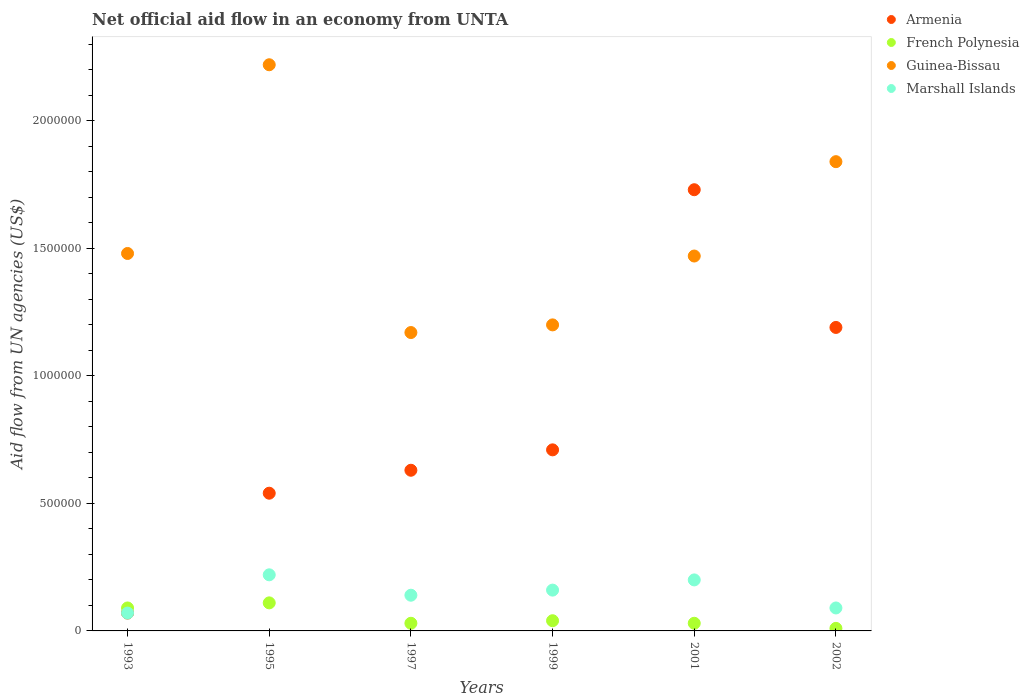What is the net official aid flow in French Polynesia in 2002?
Your answer should be compact. 10000. Across all years, what is the maximum net official aid flow in Marshall Islands?
Keep it short and to the point. 2.20e+05. In which year was the net official aid flow in Armenia maximum?
Your response must be concise. 2001. What is the total net official aid flow in Guinea-Bissau in the graph?
Ensure brevity in your answer.  9.38e+06. What is the difference between the net official aid flow in French Polynesia in 1993 and the net official aid flow in Guinea-Bissau in 1997?
Keep it short and to the point. -1.08e+06. What is the average net official aid flow in Marshall Islands per year?
Keep it short and to the point. 1.47e+05. In the year 1999, what is the difference between the net official aid flow in Guinea-Bissau and net official aid flow in Marshall Islands?
Provide a short and direct response. 1.04e+06. In how many years, is the net official aid flow in French Polynesia greater than 2200000 US$?
Ensure brevity in your answer.  0. What is the ratio of the net official aid flow in Guinea-Bissau in 1999 to that in 2001?
Ensure brevity in your answer.  0.82. What is the difference between the highest and the second highest net official aid flow in Guinea-Bissau?
Offer a very short reply. 3.80e+05. Is the sum of the net official aid flow in French Polynesia in 1999 and 2002 greater than the maximum net official aid flow in Armenia across all years?
Ensure brevity in your answer.  No. Is it the case that in every year, the sum of the net official aid flow in French Polynesia and net official aid flow in Armenia  is greater than the net official aid flow in Marshall Islands?
Keep it short and to the point. Yes. Does the net official aid flow in Armenia monotonically increase over the years?
Make the answer very short. No. How many years are there in the graph?
Your answer should be compact. 6. What is the difference between two consecutive major ticks on the Y-axis?
Offer a very short reply. 5.00e+05. Are the values on the major ticks of Y-axis written in scientific E-notation?
Offer a terse response. No. Does the graph contain any zero values?
Keep it short and to the point. No. How many legend labels are there?
Provide a short and direct response. 4. How are the legend labels stacked?
Your answer should be compact. Vertical. What is the title of the graph?
Offer a terse response. Net official aid flow in an economy from UNTA. Does "Denmark" appear as one of the legend labels in the graph?
Give a very brief answer. No. What is the label or title of the Y-axis?
Your response must be concise. Aid flow from UN agencies (US$). What is the Aid flow from UN agencies (US$) of French Polynesia in 1993?
Offer a terse response. 9.00e+04. What is the Aid flow from UN agencies (US$) in Guinea-Bissau in 1993?
Ensure brevity in your answer.  1.48e+06. What is the Aid flow from UN agencies (US$) in Armenia in 1995?
Your answer should be compact. 5.40e+05. What is the Aid flow from UN agencies (US$) of French Polynesia in 1995?
Give a very brief answer. 1.10e+05. What is the Aid flow from UN agencies (US$) of Guinea-Bissau in 1995?
Provide a short and direct response. 2.22e+06. What is the Aid flow from UN agencies (US$) of Marshall Islands in 1995?
Provide a short and direct response. 2.20e+05. What is the Aid flow from UN agencies (US$) of Armenia in 1997?
Keep it short and to the point. 6.30e+05. What is the Aid flow from UN agencies (US$) in Guinea-Bissau in 1997?
Your response must be concise. 1.17e+06. What is the Aid flow from UN agencies (US$) in Armenia in 1999?
Offer a very short reply. 7.10e+05. What is the Aid flow from UN agencies (US$) in Guinea-Bissau in 1999?
Provide a short and direct response. 1.20e+06. What is the Aid flow from UN agencies (US$) in Armenia in 2001?
Provide a succinct answer. 1.73e+06. What is the Aid flow from UN agencies (US$) in French Polynesia in 2001?
Offer a very short reply. 3.00e+04. What is the Aid flow from UN agencies (US$) in Guinea-Bissau in 2001?
Give a very brief answer. 1.47e+06. What is the Aid flow from UN agencies (US$) of Marshall Islands in 2001?
Give a very brief answer. 2.00e+05. What is the Aid flow from UN agencies (US$) of Armenia in 2002?
Your answer should be very brief. 1.19e+06. What is the Aid flow from UN agencies (US$) of Guinea-Bissau in 2002?
Provide a short and direct response. 1.84e+06. What is the Aid flow from UN agencies (US$) in Marshall Islands in 2002?
Offer a terse response. 9.00e+04. Across all years, what is the maximum Aid flow from UN agencies (US$) of Armenia?
Offer a terse response. 1.73e+06. Across all years, what is the maximum Aid flow from UN agencies (US$) in French Polynesia?
Offer a very short reply. 1.10e+05. Across all years, what is the maximum Aid flow from UN agencies (US$) of Guinea-Bissau?
Make the answer very short. 2.22e+06. Across all years, what is the minimum Aid flow from UN agencies (US$) in Armenia?
Your answer should be very brief. 7.00e+04. Across all years, what is the minimum Aid flow from UN agencies (US$) of French Polynesia?
Offer a terse response. 10000. Across all years, what is the minimum Aid flow from UN agencies (US$) of Guinea-Bissau?
Give a very brief answer. 1.17e+06. Across all years, what is the minimum Aid flow from UN agencies (US$) of Marshall Islands?
Keep it short and to the point. 7.00e+04. What is the total Aid flow from UN agencies (US$) of Armenia in the graph?
Offer a very short reply. 4.87e+06. What is the total Aid flow from UN agencies (US$) in French Polynesia in the graph?
Offer a terse response. 3.10e+05. What is the total Aid flow from UN agencies (US$) in Guinea-Bissau in the graph?
Provide a succinct answer. 9.38e+06. What is the total Aid flow from UN agencies (US$) of Marshall Islands in the graph?
Provide a succinct answer. 8.80e+05. What is the difference between the Aid flow from UN agencies (US$) in Armenia in 1993 and that in 1995?
Provide a short and direct response. -4.70e+05. What is the difference between the Aid flow from UN agencies (US$) of French Polynesia in 1993 and that in 1995?
Your answer should be very brief. -2.00e+04. What is the difference between the Aid flow from UN agencies (US$) in Guinea-Bissau in 1993 and that in 1995?
Offer a very short reply. -7.40e+05. What is the difference between the Aid flow from UN agencies (US$) of Marshall Islands in 1993 and that in 1995?
Your response must be concise. -1.50e+05. What is the difference between the Aid flow from UN agencies (US$) of Armenia in 1993 and that in 1997?
Provide a short and direct response. -5.60e+05. What is the difference between the Aid flow from UN agencies (US$) in Guinea-Bissau in 1993 and that in 1997?
Give a very brief answer. 3.10e+05. What is the difference between the Aid flow from UN agencies (US$) in Armenia in 1993 and that in 1999?
Keep it short and to the point. -6.40e+05. What is the difference between the Aid flow from UN agencies (US$) in Marshall Islands in 1993 and that in 1999?
Offer a very short reply. -9.00e+04. What is the difference between the Aid flow from UN agencies (US$) of Armenia in 1993 and that in 2001?
Provide a short and direct response. -1.66e+06. What is the difference between the Aid flow from UN agencies (US$) of Guinea-Bissau in 1993 and that in 2001?
Ensure brevity in your answer.  10000. What is the difference between the Aid flow from UN agencies (US$) in Marshall Islands in 1993 and that in 2001?
Give a very brief answer. -1.30e+05. What is the difference between the Aid flow from UN agencies (US$) in Armenia in 1993 and that in 2002?
Your response must be concise. -1.12e+06. What is the difference between the Aid flow from UN agencies (US$) in Guinea-Bissau in 1993 and that in 2002?
Keep it short and to the point. -3.60e+05. What is the difference between the Aid flow from UN agencies (US$) in Armenia in 1995 and that in 1997?
Make the answer very short. -9.00e+04. What is the difference between the Aid flow from UN agencies (US$) in Guinea-Bissau in 1995 and that in 1997?
Offer a terse response. 1.05e+06. What is the difference between the Aid flow from UN agencies (US$) in Marshall Islands in 1995 and that in 1997?
Keep it short and to the point. 8.00e+04. What is the difference between the Aid flow from UN agencies (US$) of Armenia in 1995 and that in 1999?
Offer a terse response. -1.70e+05. What is the difference between the Aid flow from UN agencies (US$) in Guinea-Bissau in 1995 and that in 1999?
Provide a succinct answer. 1.02e+06. What is the difference between the Aid flow from UN agencies (US$) of Marshall Islands in 1995 and that in 1999?
Your answer should be compact. 6.00e+04. What is the difference between the Aid flow from UN agencies (US$) of Armenia in 1995 and that in 2001?
Offer a very short reply. -1.19e+06. What is the difference between the Aid flow from UN agencies (US$) of French Polynesia in 1995 and that in 2001?
Make the answer very short. 8.00e+04. What is the difference between the Aid flow from UN agencies (US$) of Guinea-Bissau in 1995 and that in 2001?
Keep it short and to the point. 7.50e+05. What is the difference between the Aid flow from UN agencies (US$) of Armenia in 1995 and that in 2002?
Ensure brevity in your answer.  -6.50e+05. What is the difference between the Aid flow from UN agencies (US$) in Guinea-Bissau in 1995 and that in 2002?
Make the answer very short. 3.80e+05. What is the difference between the Aid flow from UN agencies (US$) of Marshall Islands in 1995 and that in 2002?
Offer a terse response. 1.30e+05. What is the difference between the Aid flow from UN agencies (US$) of Armenia in 1997 and that in 1999?
Ensure brevity in your answer.  -8.00e+04. What is the difference between the Aid flow from UN agencies (US$) in French Polynesia in 1997 and that in 1999?
Your answer should be very brief. -10000. What is the difference between the Aid flow from UN agencies (US$) in Armenia in 1997 and that in 2001?
Provide a short and direct response. -1.10e+06. What is the difference between the Aid flow from UN agencies (US$) of French Polynesia in 1997 and that in 2001?
Provide a short and direct response. 0. What is the difference between the Aid flow from UN agencies (US$) of Guinea-Bissau in 1997 and that in 2001?
Keep it short and to the point. -3.00e+05. What is the difference between the Aid flow from UN agencies (US$) in Marshall Islands in 1997 and that in 2001?
Your answer should be compact. -6.00e+04. What is the difference between the Aid flow from UN agencies (US$) in Armenia in 1997 and that in 2002?
Provide a succinct answer. -5.60e+05. What is the difference between the Aid flow from UN agencies (US$) of Guinea-Bissau in 1997 and that in 2002?
Your response must be concise. -6.70e+05. What is the difference between the Aid flow from UN agencies (US$) in Marshall Islands in 1997 and that in 2002?
Ensure brevity in your answer.  5.00e+04. What is the difference between the Aid flow from UN agencies (US$) in Armenia in 1999 and that in 2001?
Offer a terse response. -1.02e+06. What is the difference between the Aid flow from UN agencies (US$) in Guinea-Bissau in 1999 and that in 2001?
Your answer should be very brief. -2.70e+05. What is the difference between the Aid flow from UN agencies (US$) in Armenia in 1999 and that in 2002?
Give a very brief answer. -4.80e+05. What is the difference between the Aid flow from UN agencies (US$) in Guinea-Bissau in 1999 and that in 2002?
Ensure brevity in your answer.  -6.40e+05. What is the difference between the Aid flow from UN agencies (US$) of Armenia in 2001 and that in 2002?
Offer a terse response. 5.40e+05. What is the difference between the Aid flow from UN agencies (US$) in French Polynesia in 2001 and that in 2002?
Ensure brevity in your answer.  2.00e+04. What is the difference between the Aid flow from UN agencies (US$) in Guinea-Bissau in 2001 and that in 2002?
Ensure brevity in your answer.  -3.70e+05. What is the difference between the Aid flow from UN agencies (US$) in Armenia in 1993 and the Aid flow from UN agencies (US$) in Guinea-Bissau in 1995?
Your response must be concise. -2.15e+06. What is the difference between the Aid flow from UN agencies (US$) in Armenia in 1993 and the Aid flow from UN agencies (US$) in Marshall Islands in 1995?
Your response must be concise. -1.50e+05. What is the difference between the Aid flow from UN agencies (US$) of French Polynesia in 1993 and the Aid flow from UN agencies (US$) of Guinea-Bissau in 1995?
Offer a very short reply. -2.13e+06. What is the difference between the Aid flow from UN agencies (US$) of Guinea-Bissau in 1993 and the Aid flow from UN agencies (US$) of Marshall Islands in 1995?
Ensure brevity in your answer.  1.26e+06. What is the difference between the Aid flow from UN agencies (US$) in Armenia in 1993 and the Aid flow from UN agencies (US$) in Guinea-Bissau in 1997?
Offer a very short reply. -1.10e+06. What is the difference between the Aid flow from UN agencies (US$) of French Polynesia in 1993 and the Aid flow from UN agencies (US$) of Guinea-Bissau in 1997?
Ensure brevity in your answer.  -1.08e+06. What is the difference between the Aid flow from UN agencies (US$) of Guinea-Bissau in 1993 and the Aid flow from UN agencies (US$) of Marshall Islands in 1997?
Ensure brevity in your answer.  1.34e+06. What is the difference between the Aid flow from UN agencies (US$) of Armenia in 1993 and the Aid flow from UN agencies (US$) of French Polynesia in 1999?
Your answer should be very brief. 3.00e+04. What is the difference between the Aid flow from UN agencies (US$) of Armenia in 1993 and the Aid flow from UN agencies (US$) of Guinea-Bissau in 1999?
Your answer should be compact. -1.13e+06. What is the difference between the Aid flow from UN agencies (US$) in Armenia in 1993 and the Aid flow from UN agencies (US$) in Marshall Islands in 1999?
Give a very brief answer. -9.00e+04. What is the difference between the Aid flow from UN agencies (US$) in French Polynesia in 1993 and the Aid flow from UN agencies (US$) in Guinea-Bissau in 1999?
Your answer should be compact. -1.11e+06. What is the difference between the Aid flow from UN agencies (US$) in Guinea-Bissau in 1993 and the Aid flow from UN agencies (US$) in Marshall Islands in 1999?
Your answer should be compact. 1.32e+06. What is the difference between the Aid flow from UN agencies (US$) of Armenia in 1993 and the Aid flow from UN agencies (US$) of Guinea-Bissau in 2001?
Offer a terse response. -1.40e+06. What is the difference between the Aid flow from UN agencies (US$) of French Polynesia in 1993 and the Aid flow from UN agencies (US$) of Guinea-Bissau in 2001?
Make the answer very short. -1.38e+06. What is the difference between the Aid flow from UN agencies (US$) in Guinea-Bissau in 1993 and the Aid flow from UN agencies (US$) in Marshall Islands in 2001?
Make the answer very short. 1.28e+06. What is the difference between the Aid flow from UN agencies (US$) of Armenia in 1993 and the Aid flow from UN agencies (US$) of French Polynesia in 2002?
Your response must be concise. 6.00e+04. What is the difference between the Aid flow from UN agencies (US$) in Armenia in 1993 and the Aid flow from UN agencies (US$) in Guinea-Bissau in 2002?
Ensure brevity in your answer.  -1.77e+06. What is the difference between the Aid flow from UN agencies (US$) in Armenia in 1993 and the Aid flow from UN agencies (US$) in Marshall Islands in 2002?
Keep it short and to the point. -2.00e+04. What is the difference between the Aid flow from UN agencies (US$) of French Polynesia in 1993 and the Aid flow from UN agencies (US$) of Guinea-Bissau in 2002?
Your response must be concise. -1.75e+06. What is the difference between the Aid flow from UN agencies (US$) of French Polynesia in 1993 and the Aid flow from UN agencies (US$) of Marshall Islands in 2002?
Provide a succinct answer. 0. What is the difference between the Aid flow from UN agencies (US$) in Guinea-Bissau in 1993 and the Aid flow from UN agencies (US$) in Marshall Islands in 2002?
Offer a terse response. 1.39e+06. What is the difference between the Aid flow from UN agencies (US$) in Armenia in 1995 and the Aid flow from UN agencies (US$) in French Polynesia in 1997?
Your answer should be compact. 5.10e+05. What is the difference between the Aid flow from UN agencies (US$) of Armenia in 1995 and the Aid flow from UN agencies (US$) of Guinea-Bissau in 1997?
Keep it short and to the point. -6.30e+05. What is the difference between the Aid flow from UN agencies (US$) of Armenia in 1995 and the Aid flow from UN agencies (US$) of Marshall Islands in 1997?
Ensure brevity in your answer.  4.00e+05. What is the difference between the Aid flow from UN agencies (US$) of French Polynesia in 1995 and the Aid flow from UN agencies (US$) of Guinea-Bissau in 1997?
Your response must be concise. -1.06e+06. What is the difference between the Aid flow from UN agencies (US$) of Guinea-Bissau in 1995 and the Aid flow from UN agencies (US$) of Marshall Islands in 1997?
Keep it short and to the point. 2.08e+06. What is the difference between the Aid flow from UN agencies (US$) in Armenia in 1995 and the Aid flow from UN agencies (US$) in French Polynesia in 1999?
Provide a short and direct response. 5.00e+05. What is the difference between the Aid flow from UN agencies (US$) of Armenia in 1995 and the Aid flow from UN agencies (US$) of Guinea-Bissau in 1999?
Make the answer very short. -6.60e+05. What is the difference between the Aid flow from UN agencies (US$) in Armenia in 1995 and the Aid flow from UN agencies (US$) in Marshall Islands in 1999?
Make the answer very short. 3.80e+05. What is the difference between the Aid flow from UN agencies (US$) of French Polynesia in 1995 and the Aid flow from UN agencies (US$) of Guinea-Bissau in 1999?
Make the answer very short. -1.09e+06. What is the difference between the Aid flow from UN agencies (US$) of Guinea-Bissau in 1995 and the Aid flow from UN agencies (US$) of Marshall Islands in 1999?
Offer a terse response. 2.06e+06. What is the difference between the Aid flow from UN agencies (US$) in Armenia in 1995 and the Aid flow from UN agencies (US$) in French Polynesia in 2001?
Provide a short and direct response. 5.10e+05. What is the difference between the Aid flow from UN agencies (US$) of Armenia in 1995 and the Aid flow from UN agencies (US$) of Guinea-Bissau in 2001?
Provide a short and direct response. -9.30e+05. What is the difference between the Aid flow from UN agencies (US$) of Armenia in 1995 and the Aid flow from UN agencies (US$) of Marshall Islands in 2001?
Keep it short and to the point. 3.40e+05. What is the difference between the Aid flow from UN agencies (US$) of French Polynesia in 1995 and the Aid flow from UN agencies (US$) of Guinea-Bissau in 2001?
Give a very brief answer. -1.36e+06. What is the difference between the Aid flow from UN agencies (US$) of Guinea-Bissau in 1995 and the Aid flow from UN agencies (US$) of Marshall Islands in 2001?
Provide a succinct answer. 2.02e+06. What is the difference between the Aid flow from UN agencies (US$) in Armenia in 1995 and the Aid flow from UN agencies (US$) in French Polynesia in 2002?
Give a very brief answer. 5.30e+05. What is the difference between the Aid flow from UN agencies (US$) in Armenia in 1995 and the Aid flow from UN agencies (US$) in Guinea-Bissau in 2002?
Your answer should be compact. -1.30e+06. What is the difference between the Aid flow from UN agencies (US$) of French Polynesia in 1995 and the Aid flow from UN agencies (US$) of Guinea-Bissau in 2002?
Ensure brevity in your answer.  -1.73e+06. What is the difference between the Aid flow from UN agencies (US$) of Guinea-Bissau in 1995 and the Aid flow from UN agencies (US$) of Marshall Islands in 2002?
Provide a short and direct response. 2.13e+06. What is the difference between the Aid flow from UN agencies (US$) of Armenia in 1997 and the Aid flow from UN agencies (US$) of French Polynesia in 1999?
Ensure brevity in your answer.  5.90e+05. What is the difference between the Aid flow from UN agencies (US$) in Armenia in 1997 and the Aid flow from UN agencies (US$) in Guinea-Bissau in 1999?
Provide a succinct answer. -5.70e+05. What is the difference between the Aid flow from UN agencies (US$) in French Polynesia in 1997 and the Aid flow from UN agencies (US$) in Guinea-Bissau in 1999?
Offer a terse response. -1.17e+06. What is the difference between the Aid flow from UN agencies (US$) of French Polynesia in 1997 and the Aid flow from UN agencies (US$) of Marshall Islands in 1999?
Keep it short and to the point. -1.30e+05. What is the difference between the Aid flow from UN agencies (US$) of Guinea-Bissau in 1997 and the Aid flow from UN agencies (US$) of Marshall Islands in 1999?
Provide a short and direct response. 1.01e+06. What is the difference between the Aid flow from UN agencies (US$) of Armenia in 1997 and the Aid flow from UN agencies (US$) of French Polynesia in 2001?
Your answer should be compact. 6.00e+05. What is the difference between the Aid flow from UN agencies (US$) of Armenia in 1997 and the Aid flow from UN agencies (US$) of Guinea-Bissau in 2001?
Your answer should be compact. -8.40e+05. What is the difference between the Aid flow from UN agencies (US$) in French Polynesia in 1997 and the Aid flow from UN agencies (US$) in Guinea-Bissau in 2001?
Make the answer very short. -1.44e+06. What is the difference between the Aid flow from UN agencies (US$) of Guinea-Bissau in 1997 and the Aid flow from UN agencies (US$) of Marshall Islands in 2001?
Offer a very short reply. 9.70e+05. What is the difference between the Aid flow from UN agencies (US$) in Armenia in 1997 and the Aid flow from UN agencies (US$) in French Polynesia in 2002?
Your answer should be very brief. 6.20e+05. What is the difference between the Aid flow from UN agencies (US$) in Armenia in 1997 and the Aid flow from UN agencies (US$) in Guinea-Bissau in 2002?
Offer a very short reply. -1.21e+06. What is the difference between the Aid flow from UN agencies (US$) of Armenia in 1997 and the Aid flow from UN agencies (US$) of Marshall Islands in 2002?
Give a very brief answer. 5.40e+05. What is the difference between the Aid flow from UN agencies (US$) of French Polynesia in 1997 and the Aid flow from UN agencies (US$) of Guinea-Bissau in 2002?
Provide a succinct answer. -1.81e+06. What is the difference between the Aid flow from UN agencies (US$) of Guinea-Bissau in 1997 and the Aid flow from UN agencies (US$) of Marshall Islands in 2002?
Your answer should be very brief. 1.08e+06. What is the difference between the Aid flow from UN agencies (US$) of Armenia in 1999 and the Aid flow from UN agencies (US$) of French Polynesia in 2001?
Your answer should be very brief. 6.80e+05. What is the difference between the Aid flow from UN agencies (US$) of Armenia in 1999 and the Aid flow from UN agencies (US$) of Guinea-Bissau in 2001?
Your response must be concise. -7.60e+05. What is the difference between the Aid flow from UN agencies (US$) of Armenia in 1999 and the Aid flow from UN agencies (US$) of Marshall Islands in 2001?
Your response must be concise. 5.10e+05. What is the difference between the Aid flow from UN agencies (US$) in French Polynesia in 1999 and the Aid flow from UN agencies (US$) in Guinea-Bissau in 2001?
Your answer should be very brief. -1.43e+06. What is the difference between the Aid flow from UN agencies (US$) of French Polynesia in 1999 and the Aid flow from UN agencies (US$) of Marshall Islands in 2001?
Offer a terse response. -1.60e+05. What is the difference between the Aid flow from UN agencies (US$) of Armenia in 1999 and the Aid flow from UN agencies (US$) of French Polynesia in 2002?
Offer a terse response. 7.00e+05. What is the difference between the Aid flow from UN agencies (US$) of Armenia in 1999 and the Aid flow from UN agencies (US$) of Guinea-Bissau in 2002?
Ensure brevity in your answer.  -1.13e+06. What is the difference between the Aid flow from UN agencies (US$) of Armenia in 1999 and the Aid flow from UN agencies (US$) of Marshall Islands in 2002?
Provide a short and direct response. 6.20e+05. What is the difference between the Aid flow from UN agencies (US$) of French Polynesia in 1999 and the Aid flow from UN agencies (US$) of Guinea-Bissau in 2002?
Provide a succinct answer. -1.80e+06. What is the difference between the Aid flow from UN agencies (US$) of Guinea-Bissau in 1999 and the Aid flow from UN agencies (US$) of Marshall Islands in 2002?
Give a very brief answer. 1.11e+06. What is the difference between the Aid flow from UN agencies (US$) of Armenia in 2001 and the Aid flow from UN agencies (US$) of French Polynesia in 2002?
Make the answer very short. 1.72e+06. What is the difference between the Aid flow from UN agencies (US$) of Armenia in 2001 and the Aid flow from UN agencies (US$) of Guinea-Bissau in 2002?
Offer a very short reply. -1.10e+05. What is the difference between the Aid flow from UN agencies (US$) in Armenia in 2001 and the Aid flow from UN agencies (US$) in Marshall Islands in 2002?
Keep it short and to the point. 1.64e+06. What is the difference between the Aid flow from UN agencies (US$) in French Polynesia in 2001 and the Aid flow from UN agencies (US$) in Guinea-Bissau in 2002?
Your answer should be compact. -1.81e+06. What is the difference between the Aid flow from UN agencies (US$) of French Polynesia in 2001 and the Aid flow from UN agencies (US$) of Marshall Islands in 2002?
Ensure brevity in your answer.  -6.00e+04. What is the difference between the Aid flow from UN agencies (US$) of Guinea-Bissau in 2001 and the Aid flow from UN agencies (US$) of Marshall Islands in 2002?
Provide a succinct answer. 1.38e+06. What is the average Aid flow from UN agencies (US$) in Armenia per year?
Provide a succinct answer. 8.12e+05. What is the average Aid flow from UN agencies (US$) of French Polynesia per year?
Provide a short and direct response. 5.17e+04. What is the average Aid flow from UN agencies (US$) of Guinea-Bissau per year?
Your answer should be compact. 1.56e+06. What is the average Aid flow from UN agencies (US$) in Marshall Islands per year?
Provide a short and direct response. 1.47e+05. In the year 1993, what is the difference between the Aid flow from UN agencies (US$) of Armenia and Aid flow from UN agencies (US$) of French Polynesia?
Give a very brief answer. -2.00e+04. In the year 1993, what is the difference between the Aid flow from UN agencies (US$) in Armenia and Aid flow from UN agencies (US$) in Guinea-Bissau?
Provide a succinct answer. -1.41e+06. In the year 1993, what is the difference between the Aid flow from UN agencies (US$) in Armenia and Aid flow from UN agencies (US$) in Marshall Islands?
Keep it short and to the point. 0. In the year 1993, what is the difference between the Aid flow from UN agencies (US$) in French Polynesia and Aid flow from UN agencies (US$) in Guinea-Bissau?
Your answer should be compact. -1.39e+06. In the year 1993, what is the difference between the Aid flow from UN agencies (US$) of French Polynesia and Aid flow from UN agencies (US$) of Marshall Islands?
Your response must be concise. 2.00e+04. In the year 1993, what is the difference between the Aid flow from UN agencies (US$) in Guinea-Bissau and Aid flow from UN agencies (US$) in Marshall Islands?
Offer a very short reply. 1.41e+06. In the year 1995, what is the difference between the Aid flow from UN agencies (US$) of Armenia and Aid flow from UN agencies (US$) of French Polynesia?
Offer a terse response. 4.30e+05. In the year 1995, what is the difference between the Aid flow from UN agencies (US$) in Armenia and Aid flow from UN agencies (US$) in Guinea-Bissau?
Ensure brevity in your answer.  -1.68e+06. In the year 1995, what is the difference between the Aid flow from UN agencies (US$) in French Polynesia and Aid flow from UN agencies (US$) in Guinea-Bissau?
Offer a very short reply. -2.11e+06. In the year 1995, what is the difference between the Aid flow from UN agencies (US$) in French Polynesia and Aid flow from UN agencies (US$) in Marshall Islands?
Your response must be concise. -1.10e+05. In the year 1997, what is the difference between the Aid flow from UN agencies (US$) in Armenia and Aid flow from UN agencies (US$) in Guinea-Bissau?
Your answer should be very brief. -5.40e+05. In the year 1997, what is the difference between the Aid flow from UN agencies (US$) in French Polynesia and Aid flow from UN agencies (US$) in Guinea-Bissau?
Make the answer very short. -1.14e+06. In the year 1997, what is the difference between the Aid flow from UN agencies (US$) of Guinea-Bissau and Aid flow from UN agencies (US$) of Marshall Islands?
Provide a short and direct response. 1.03e+06. In the year 1999, what is the difference between the Aid flow from UN agencies (US$) of Armenia and Aid flow from UN agencies (US$) of French Polynesia?
Your answer should be very brief. 6.70e+05. In the year 1999, what is the difference between the Aid flow from UN agencies (US$) of Armenia and Aid flow from UN agencies (US$) of Guinea-Bissau?
Provide a succinct answer. -4.90e+05. In the year 1999, what is the difference between the Aid flow from UN agencies (US$) of Armenia and Aid flow from UN agencies (US$) of Marshall Islands?
Give a very brief answer. 5.50e+05. In the year 1999, what is the difference between the Aid flow from UN agencies (US$) of French Polynesia and Aid flow from UN agencies (US$) of Guinea-Bissau?
Provide a short and direct response. -1.16e+06. In the year 1999, what is the difference between the Aid flow from UN agencies (US$) in French Polynesia and Aid flow from UN agencies (US$) in Marshall Islands?
Make the answer very short. -1.20e+05. In the year 1999, what is the difference between the Aid flow from UN agencies (US$) in Guinea-Bissau and Aid flow from UN agencies (US$) in Marshall Islands?
Ensure brevity in your answer.  1.04e+06. In the year 2001, what is the difference between the Aid flow from UN agencies (US$) of Armenia and Aid flow from UN agencies (US$) of French Polynesia?
Keep it short and to the point. 1.70e+06. In the year 2001, what is the difference between the Aid flow from UN agencies (US$) in Armenia and Aid flow from UN agencies (US$) in Marshall Islands?
Your answer should be compact. 1.53e+06. In the year 2001, what is the difference between the Aid flow from UN agencies (US$) in French Polynesia and Aid flow from UN agencies (US$) in Guinea-Bissau?
Your response must be concise. -1.44e+06. In the year 2001, what is the difference between the Aid flow from UN agencies (US$) of French Polynesia and Aid flow from UN agencies (US$) of Marshall Islands?
Make the answer very short. -1.70e+05. In the year 2001, what is the difference between the Aid flow from UN agencies (US$) in Guinea-Bissau and Aid flow from UN agencies (US$) in Marshall Islands?
Give a very brief answer. 1.27e+06. In the year 2002, what is the difference between the Aid flow from UN agencies (US$) in Armenia and Aid flow from UN agencies (US$) in French Polynesia?
Make the answer very short. 1.18e+06. In the year 2002, what is the difference between the Aid flow from UN agencies (US$) of Armenia and Aid flow from UN agencies (US$) of Guinea-Bissau?
Offer a very short reply. -6.50e+05. In the year 2002, what is the difference between the Aid flow from UN agencies (US$) of Armenia and Aid flow from UN agencies (US$) of Marshall Islands?
Provide a succinct answer. 1.10e+06. In the year 2002, what is the difference between the Aid flow from UN agencies (US$) of French Polynesia and Aid flow from UN agencies (US$) of Guinea-Bissau?
Provide a succinct answer. -1.83e+06. In the year 2002, what is the difference between the Aid flow from UN agencies (US$) of Guinea-Bissau and Aid flow from UN agencies (US$) of Marshall Islands?
Your answer should be compact. 1.75e+06. What is the ratio of the Aid flow from UN agencies (US$) in Armenia in 1993 to that in 1995?
Provide a short and direct response. 0.13. What is the ratio of the Aid flow from UN agencies (US$) in French Polynesia in 1993 to that in 1995?
Your response must be concise. 0.82. What is the ratio of the Aid flow from UN agencies (US$) of Guinea-Bissau in 1993 to that in 1995?
Provide a short and direct response. 0.67. What is the ratio of the Aid flow from UN agencies (US$) in Marshall Islands in 1993 to that in 1995?
Give a very brief answer. 0.32. What is the ratio of the Aid flow from UN agencies (US$) of Armenia in 1993 to that in 1997?
Offer a very short reply. 0.11. What is the ratio of the Aid flow from UN agencies (US$) in Guinea-Bissau in 1993 to that in 1997?
Make the answer very short. 1.26. What is the ratio of the Aid flow from UN agencies (US$) of Marshall Islands in 1993 to that in 1997?
Your answer should be compact. 0.5. What is the ratio of the Aid flow from UN agencies (US$) of Armenia in 1993 to that in 1999?
Give a very brief answer. 0.1. What is the ratio of the Aid flow from UN agencies (US$) of French Polynesia in 1993 to that in 1999?
Offer a very short reply. 2.25. What is the ratio of the Aid flow from UN agencies (US$) of Guinea-Bissau in 1993 to that in 1999?
Provide a short and direct response. 1.23. What is the ratio of the Aid flow from UN agencies (US$) in Marshall Islands in 1993 to that in 1999?
Offer a terse response. 0.44. What is the ratio of the Aid flow from UN agencies (US$) of Armenia in 1993 to that in 2001?
Your response must be concise. 0.04. What is the ratio of the Aid flow from UN agencies (US$) of French Polynesia in 1993 to that in 2001?
Give a very brief answer. 3. What is the ratio of the Aid flow from UN agencies (US$) in Guinea-Bissau in 1993 to that in 2001?
Give a very brief answer. 1.01. What is the ratio of the Aid flow from UN agencies (US$) in Marshall Islands in 1993 to that in 2001?
Offer a very short reply. 0.35. What is the ratio of the Aid flow from UN agencies (US$) in Armenia in 1993 to that in 2002?
Your answer should be very brief. 0.06. What is the ratio of the Aid flow from UN agencies (US$) of French Polynesia in 1993 to that in 2002?
Keep it short and to the point. 9. What is the ratio of the Aid flow from UN agencies (US$) in Guinea-Bissau in 1993 to that in 2002?
Provide a succinct answer. 0.8. What is the ratio of the Aid flow from UN agencies (US$) in Marshall Islands in 1993 to that in 2002?
Provide a succinct answer. 0.78. What is the ratio of the Aid flow from UN agencies (US$) of Armenia in 1995 to that in 1997?
Your answer should be compact. 0.86. What is the ratio of the Aid flow from UN agencies (US$) of French Polynesia in 1995 to that in 1997?
Ensure brevity in your answer.  3.67. What is the ratio of the Aid flow from UN agencies (US$) of Guinea-Bissau in 1995 to that in 1997?
Make the answer very short. 1.9. What is the ratio of the Aid flow from UN agencies (US$) of Marshall Islands in 1995 to that in 1997?
Your answer should be compact. 1.57. What is the ratio of the Aid flow from UN agencies (US$) in Armenia in 1995 to that in 1999?
Give a very brief answer. 0.76. What is the ratio of the Aid flow from UN agencies (US$) in French Polynesia in 1995 to that in 1999?
Offer a terse response. 2.75. What is the ratio of the Aid flow from UN agencies (US$) of Guinea-Bissau in 1995 to that in 1999?
Keep it short and to the point. 1.85. What is the ratio of the Aid flow from UN agencies (US$) of Marshall Islands in 1995 to that in 1999?
Provide a succinct answer. 1.38. What is the ratio of the Aid flow from UN agencies (US$) of Armenia in 1995 to that in 2001?
Give a very brief answer. 0.31. What is the ratio of the Aid flow from UN agencies (US$) in French Polynesia in 1995 to that in 2001?
Offer a terse response. 3.67. What is the ratio of the Aid flow from UN agencies (US$) in Guinea-Bissau in 1995 to that in 2001?
Offer a very short reply. 1.51. What is the ratio of the Aid flow from UN agencies (US$) of Marshall Islands in 1995 to that in 2001?
Provide a succinct answer. 1.1. What is the ratio of the Aid flow from UN agencies (US$) in Armenia in 1995 to that in 2002?
Offer a very short reply. 0.45. What is the ratio of the Aid flow from UN agencies (US$) in French Polynesia in 1995 to that in 2002?
Keep it short and to the point. 11. What is the ratio of the Aid flow from UN agencies (US$) of Guinea-Bissau in 1995 to that in 2002?
Your answer should be compact. 1.21. What is the ratio of the Aid flow from UN agencies (US$) in Marshall Islands in 1995 to that in 2002?
Ensure brevity in your answer.  2.44. What is the ratio of the Aid flow from UN agencies (US$) of Armenia in 1997 to that in 1999?
Keep it short and to the point. 0.89. What is the ratio of the Aid flow from UN agencies (US$) in Guinea-Bissau in 1997 to that in 1999?
Keep it short and to the point. 0.97. What is the ratio of the Aid flow from UN agencies (US$) in Armenia in 1997 to that in 2001?
Keep it short and to the point. 0.36. What is the ratio of the Aid flow from UN agencies (US$) in French Polynesia in 1997 to that in 2001?
Offer a terse response. 1. What is the ratio of the Aid flow from UN agencies (US$) in Guinea-Bissau in 1997 to that in 2001?
Provide a short and direct response. 0.8. What is the ratio of the Aid flow from UN agencies (US$) of Marshall Islands in 1997 to that in 2001?
Offer a very short reply. 0.7. What is the ratio of the Aid flow from UN agencies (US$) in Armenia in 1997 to that in 2002?
Your response must be concise. 0.53. What is the ratio of the Aid flow from UN agencies (US$) in French Polynesia in 1997 to that in 2002?
Give a very brief answer. 3. What is the ratio of the Aid flow from UN agencies (US$) of Guinea-Bissau in 1997 to that in 2002?
Your answer should be very brief. 0.64. What is the ratio of the Aid flow from UN agencies (US$) of Marshall Islands in 1997 to that in 2002?
Offer a very short reply. 1.56. What is the ratio of the Aid flow from UN agencies (US$) of Armenia in 1999 to that in 2001?
Your answer should be very brief. 0.41. What is the ratio of the Aid flow from UN agencies (US$) of French Polynesia in 1999 to that in 2001?
Your answer should be compact. 1.33. What is the ratio of the Aid flow from UN agencies (US$) of Guinea-Bissau in 1999 to that in 2001?
Provide a short and direct response. 0.82. What is the ratio of the Aid flow from UN agencies (US$) of Armenia in 1999 to that in 2002?
Provide a short and direct response. 0.6. What is the ratio of the Aid flow from UN agencies (US$) of Guinea-Bissau in 1999 to that in 2002?
Your answer should be compact. 0.65. What is the ratio of the Aid flow from UN agencies (US$) of Marshall Islands in 1999 to that in 2002?
Provide a succinct answer. 1.78. What is the ratio of the Aid flow from UN agencies (US$) of Armenia in 2001 to that in 2002?
Your answer should be compact. 1.45. What is the ratio of the Aid flow from UN agencies (US$) of French Polynesia in 2001 to that in 2002?
Ensure brevity in your answer.  3. What is the ratio of the Aid flow from UN agencies (US$) of Guinea-Bissau in 2001 to that in 2002?
Give a very brief answer. 0.8. What is the ratio of the Aid flow from UN agencies (US$) in Marshall Islands in 2001 to that in 2002?
Your answer should be very brief. 2.22. What is the difference between the highest and the second highest Aid flow from UN agencies (US$) of Armenia?
Provide a succinct answer. 5.40e+05. What is the difference between the highest and the second highest Aid flow from UN agencies (US$) in French Polynesia?
Offer a terse response. 2.00e+04. What is the difference between the highest and the second highest Aid flow from UN agencies (US$) of Guinea-Bissau?
Keep it short and to the point. 3.80e+05. What is the difference between the highest and the lowest Aid flow from UN agencies (US$) in Armenia?
Offer a terse response. 1.66e+06. What is the difference between the highest and the lowest Aid flow from UN agencies (US$) in French Polynesia?
Your answer should be compact. 1.00e+05. What is the difference between the highest and the lowest Aid flow from UN agencies (US$) of Guinea-Bissau?
Offer a very short reply. 1.05e+06. 